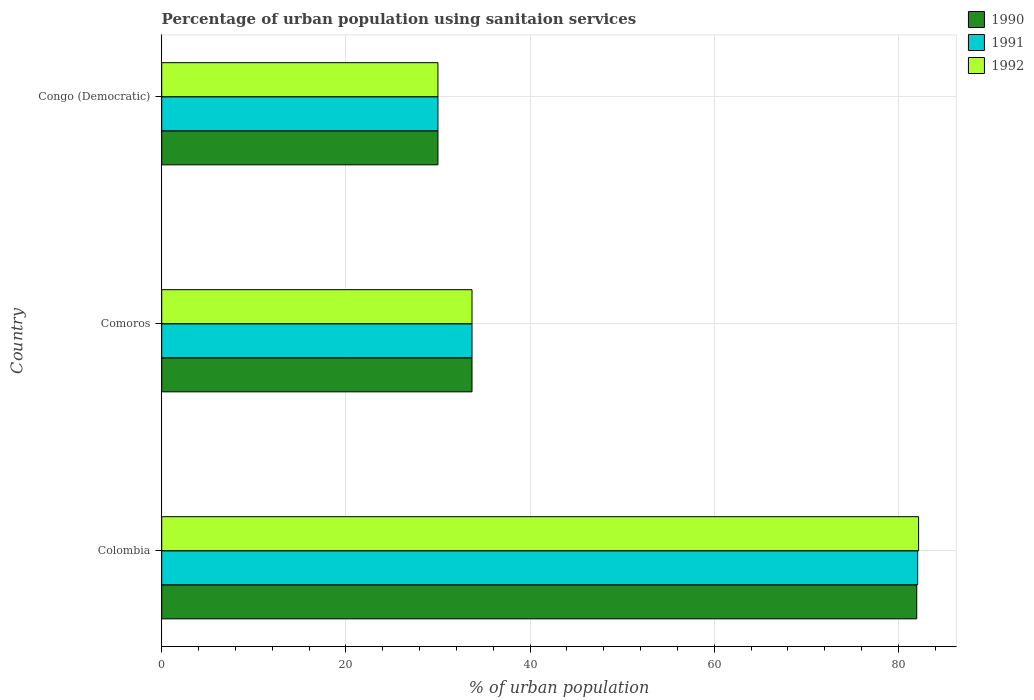How many different coloured bars are there?
Provide a succinct answer. 3. Are the number of bars on each tick of the Y-axis equal?
Provide a short and direct response. Yes. How many bars are there on the 3rd tick from the top?
Provide a succinct answer. 3. What is the percentage of urban population using sanitaion services in 1990 in Comoros?
Your answer should be very brief. 33.7. In which country was the percentage of urban population using sanitaion services in 1990 minimum?
Your answer should be very brief. Congo (Democratic). What is the total percentage of urban population using sanitaion services in 1990 in the graph?
Your answer should be compact. 145.7. What is the difference between the percentage of urban population using sanitaion services in 1992 in Congo (Democratic) and the percentage of urban population using sanitaion services in 1991 in Colombia?
Offer a terse response. -52.1. What is the average percentage of urban population using sanitaion services in 1990 per country?
Your answer should be very brief. 48.57. What is the difference between the percentage of urban population using sanitaion services in 1991 and percentage of urban population using sanitaion services in 1990 in Colombia?
Offer a very short reply. 0.1. What is the ratio of the percentage of urban population using sanitaion services in 1991 in Comoros to that in Congo (Democratic)?
Keep it short and to the point. 1.12. Is the percentage of urban population using sanitaion services in 1991 in Colombia less than that in Congo (Democratic)?
Your answer should be very brief. No. What is the difference between the highest and the second highest percentage of urban population using sanitaion services in 1990?
Your response must be concise. 48.3. What is the difference between the highest and the lowest percentage of urban population using sanitaion services in 1990?
Make the answer very short. 52. In how many countries, is the percentage of urban population using sanitaion services in 1991 greater than the average percentage of urban population using sanitaion services in 1991 taken over all countries?
Keep it short and to the point. 1. Is the sum of the percentage of urban population using sanitaion services in 1990 in Colombia and Congo (Democratic) greater than the maximum percentage of urban population using sanitaion services in 1992 across all countries?
Ensure brevity in your answer.  Yes. What does the 2nd bar from the top in Congo (Democratic) represents?
Offer a very short reply. 1991. What does the 3rd bar from the bottom in Colombia represents?
Offer a very short reply. 1992. How many bars are there?
Offer a terse response. 9. What is the difference between two consecutive major ticks on the X-axis?
Give a very brief answer. 20. Does the graph contain any zero values?
Keep it short and to the point. No. How are the legend labels stacked?
Offer a terse response. Vertical. What is the title of the graph?
Your answer should be very brief. Percentage of urban population using sanitaion services. What is the label or title of the X-axis?
Provide a short and direct response. % of urban population. What is the % of urban population in 1990 in Colombia?
Provide a short and direct response. 82. What is the % of urban population in 1991 in Colombia?
Your response must be concise. 82.1. What is the % of urban population of 1992 in Colombia?
Your response must be concise. 82.2. What is the % of urban population of 1990 in Comoros?
Offer a terse response. 33.7. What is the % of urban population of 1991 in Comoros?
Your response must be concise. 33.7. What is the % of urban population in 1992 in Comoros?
Your answer should be very brief. 33.7. What is the % of urban population in 1990 in Congo (Democratic)?
Offer a very short reply. 30. Across all countries, what is the maximum % of urban population in 1990?
Give a very brief answer. 82. Across all countries, what is the maximum % of urban population of 1991?
Make the answer very short. 82.1. Across all countries, what is the maximum % of urban population in 1992?
Give a very brief answer. 82.2. Across all countries, what is the minimum % of urban population of 1990?
Offer a very short reply. 30. Across all countries, what is the minimum % of urban population in 1991?
Offer a very short reply. 30. What is the total % of urban population of 1990 in the graph?
Provide a short and direct response. 145.7. What is the total % of urban population in 1991 in the graph?
Keep it short and to the point. 145.8. What is the total % of urban population of 1992 in the graph?
Keep it short and to the point. 145.9. What is the difference between the % of urban population of 1990 in Colombia and that in Comoros?
Provide a succinct answer. 48.3. What is the difference between the % of urban population of 1991 in Colombia and that in Comoros?
Keep it short and to the point. 48.4. What is the difference between the % of urban population of 1992 in Colombia and that in Comoros?
Make the answer very short. 48.5. What is the difference between the % of urban population of 1990 in Colombia and that in Congo (Democratic)?
Your answer should be compact. 52. What is the difference between the % of urban population of 1991 in Colombia and that in Congo (Democratic)?
Your answer should be very brief. 52.1. What is the difference between the % of urban population of 1992 in Colombia and that in Congo (Democratic)?
Offer a very short reply. 52.2. What is the difference between the % of urban population of 1990 in Comoros and that in Congo (Democratic)?
Make the answer very short. 3.7. What is the difference between the % of urban population in 1990 in Colombia and the % of urban population in 1991 in Comoros?
Give a very brief answer. 48.3. What is the difference between the % of urban population in 1990 in Colombia and the % of urban population in 1992 in Comoros?
Your answer should be very brief. 48.3. What is the difference between the % of urban population in 1991 in Colombia and the % of urban population in 1992 in Comoros?
Offer a terse response. 48.4. What is the difference between the % of urban population of 1990 in Colombia and the % of urban population of 1991 in Congo (Democratic)?
Your answer should be very brief. 52. What is the difference between the % of urban population of 1991 in Colombia and the % of urban population of 1992 in Congo (Democratic)?
Provide a succinct answer. 52.1. What is the difference between the % of urban population in 1991 in Comoros and the % of urban population in 1992 in Congo (Democratic)?
Ensure brevity in your answer.  3.7. What is the average % of urban population in 1990 per country?
Provide a succinct answer. 48.57. What is the average % of urban population of 1991 per country?
Your answer should be compact. 48.6. What is the average % of urban population of 1992 per country?
Ensure brevity in your answer.  48.63. What is the difference between the % of urban population in 1990 and % of urban population in 1992 in Colombia?
Your response must be concise. -0.2. What is the difference between the % of urban population in 1990 and % of urban population in 1991 in Comoros?
Make the answer very short. 0. What is the difference between the % of urban population in 1990 and % of urban population in 1992 in Comoros?
Offer a very short reply. 0. What is the difference between the % of urban population of 1990 and % of urban population of 1991 in Congo (Democratic)?
Make the answer very short. 0. What is the ratio of the % of urban population in 1990 in Colombia to that in Comoros?
Keep it short and to the point. 2.43. What is the ratio of the % of urban population in 1991 in Colombia to that in Comoros?
Keep it short and to the point. 2.44. What is the ratio of the % of urban population of 1992 in Colombia to that in Comoros?
Make the answer very short. 2.44. What is the ratio of the % of urban population in 1990 in Colombia to that in Congo (Democratic)?
Give a very brief answer. 2.73. What is the ratio of the % of urban population of 1991 in Colombia to that in Congo (Democratic)?
Provide a short and direct response. 2.74. What is the ratio of the % of urban population of 1992 in Colombia to that in Congo (Democratic)?
Keep it short and to the point. 2.74. What is the ratio of the % of urban population of 1990 in Comoros to that in Congo (Democratic)?
Offer a very short reply. 1.12. What is the ratio of the % of urban population of 1991 in Comoros to that in Congo (Democratic)?
Offer a terse response. 1.12. What is the ratio of the % of urban population in 1992 in Comoros to that in Congo (Democratic)?
Provide a short and direct response. 1.12. What is the difference between the highest and the second highest % of urban population in 1990?
Provide a succinct answer. 48.3. What is the difference between the highest and the second highest % of urban population in 1991?
Offer a terse response. 48.4. What is the difference between the highest and the second highest % of urban population in 1992?
Your answer should be compact. 48.5. What is the difference between the highest and the lowest % of urban population of 1990?
Offer a very short reply. 52. What is the difference between the highest and the lowest % of urban population in 1991?
Your answer should be compact. 52.1. What is the difference between the highest and the lowest % of urban population in 1992?
Ensure brevity in your answer.  52.2. 